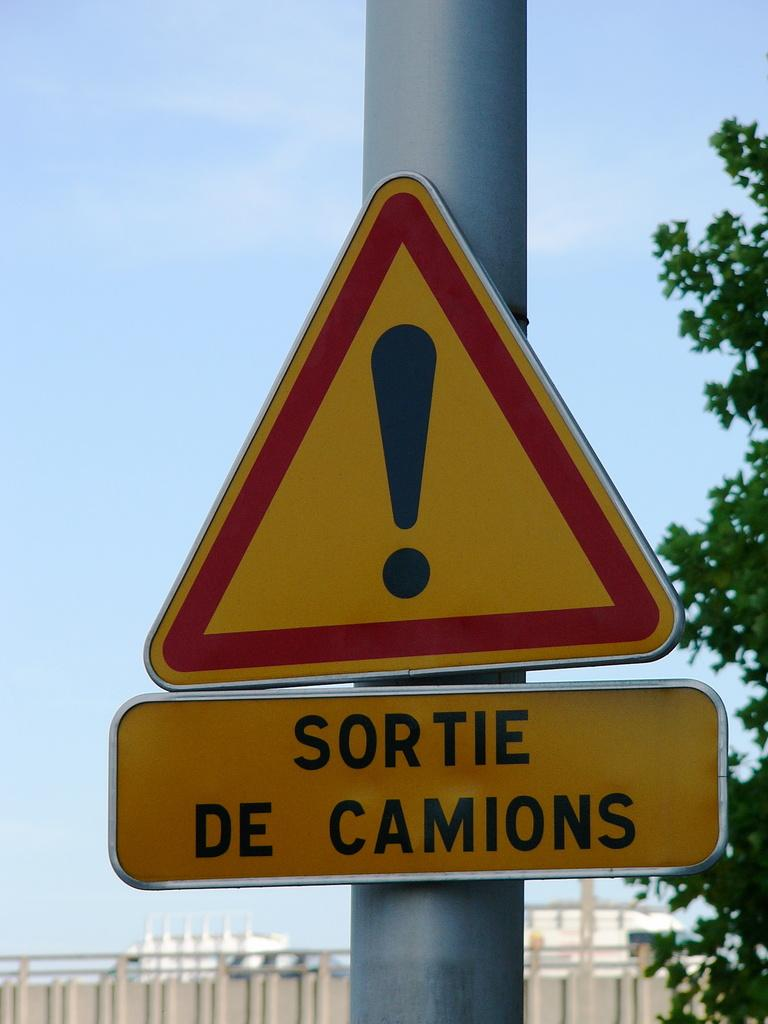What type of structure can be seen in the image? There is a fence in the image. What other natural elements are present in the image? There are trees in the image. Can you describe any man-made objects in the image? There is a pole in the image. What might the board with text be used for? The board with text might be used for displaying information or advertising. What can be seen in the background of the image? The sky is visible in the background of the image. What type of bean is growing on the pole in the image? There are no beans present in the image; it features a pole, a fence, trees, and a board with text. How many lines can be seen on the board with text in the image? The number of lines on the board with text cannot be determined from the image. 